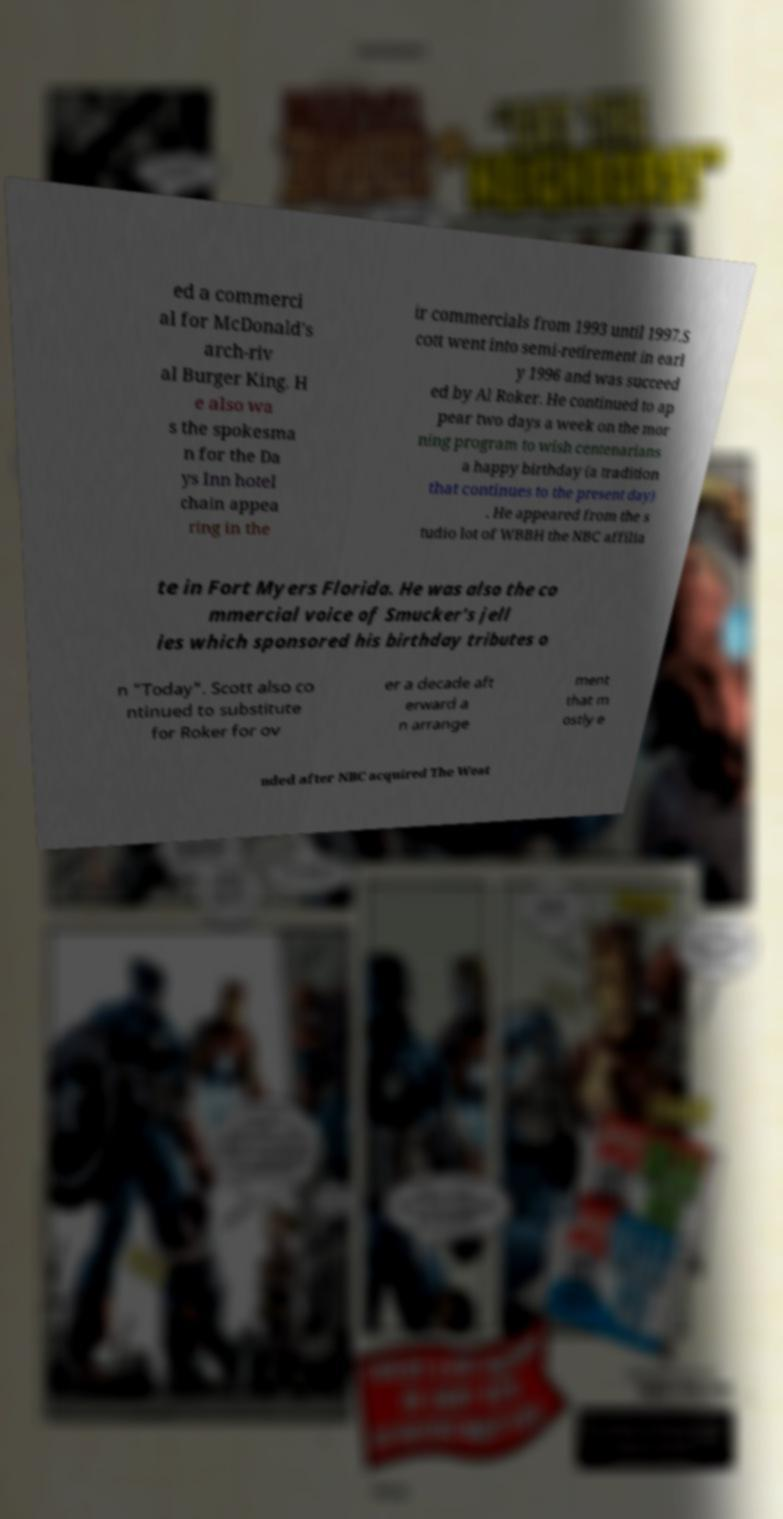What messages or text are displayed in this image? I need them in a readable, typed format. ed a commerci al for McDonald's arch-riv al Burger King. H e also wa s the spokesma n for the Da ys Inn hotel chain appea ring in the ir commercials from 1993 until 1997.S cott went into semi-retirement in earl y 1996 and was succeed ed by Al Roker. He continued to ap pear two days a week on the mor ning program to wish centenarians a happy birthday (a tradition that continues to the present day) . He appeared from the s tudio lot of WBBH the NBC affilia te in Fort Myers Florida. He was also the co mmercial voice of Smucker's jell ies which sponsored his birthday tributes o n "Today". Scott also co ntinued to substitute for Roker for ov er a decade aft erward a n arrange ment that m ostly e nded after NBC acquired The Weat 